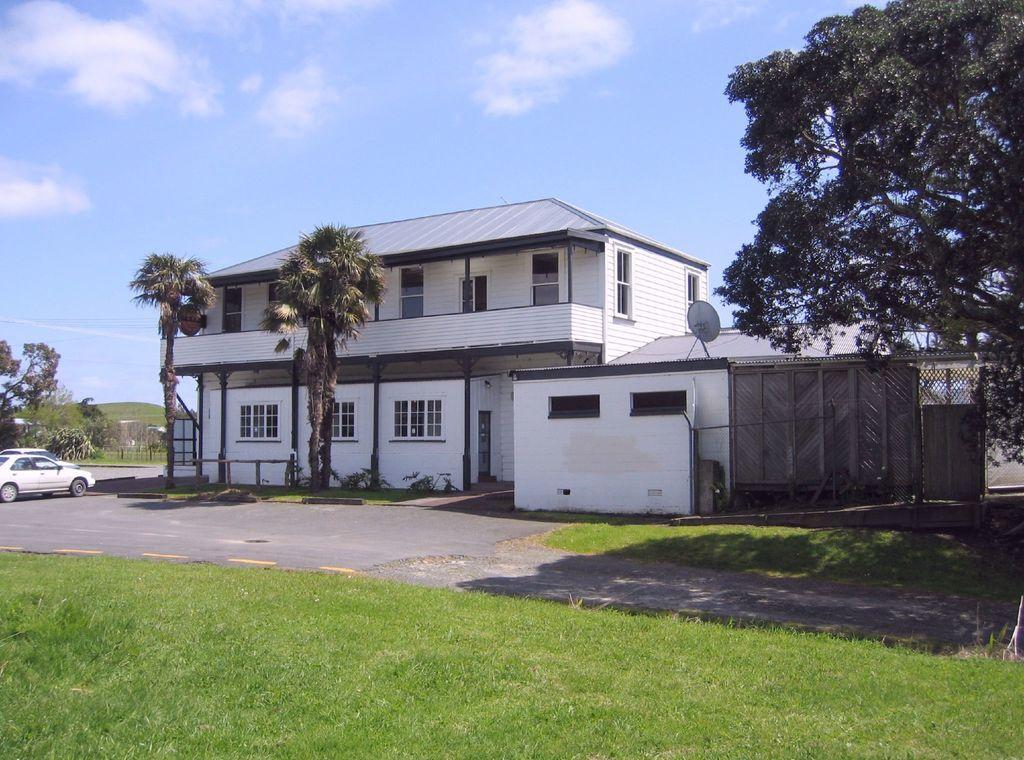In one or two sentences, can you explain what this image depicts? In this image there is grass at the bottom. There are vehicles, trees on the left corner. There is a tree on the right corner. We can see the road, there is a building with windows, there are trees in the background. And there is sky at the top. 